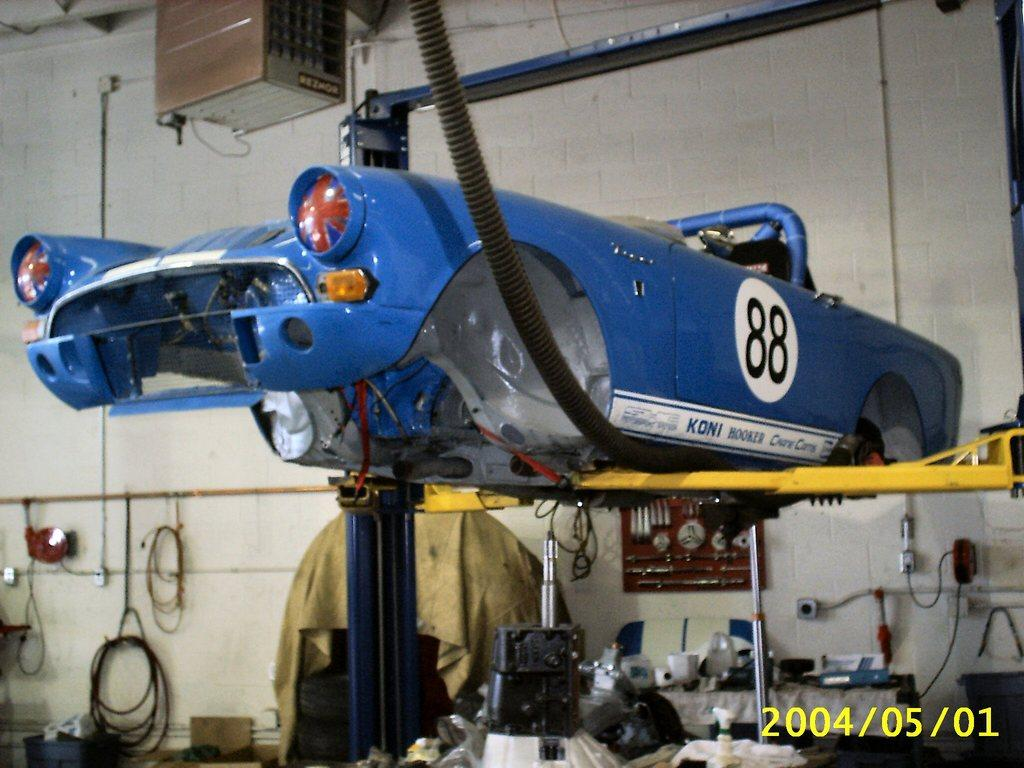<image>
Create a compact narrative representing the image presented. an old blue sports car with 88 on the side up on a jack 